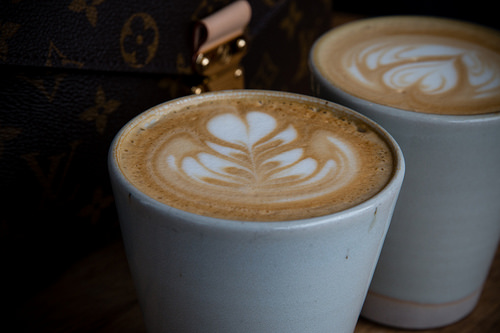<image>
Is there a heart in the cup? Yes. The heart is contained within or inside the cup, showing a containment relationship. Is the heart in the coffee cup? Yes. The heart is contained within or inside the coffee cup, showing a containment relationship. Is there a coffee on the cup? No. The coffee is not positioned on the cup. They may be near each other, but the coffee is not supported by or resting on top of the cup. 